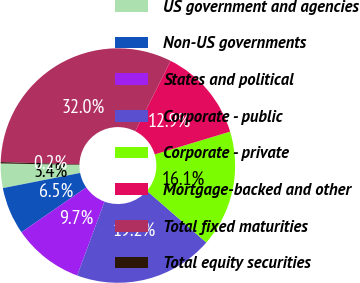Convert chart. <chart><loc_0><loc_0><loc_500><loc_500><pie_chart><fcel>US government and agencies<fcel>Non-US governments<fcel>States and political<fcel>Corporate - public<fcel>Corporate - private<fcel>Mortgage-backed and other<fcel>Total fixed maturities<fcel>Total equity securities<nl><fcel>3.37%<fcel>6.55%<fcel>9.72%<fcel>19.25%<fcel>16.07%<fcel>12.9%<fcel>31.95%<fcel>0.19%<nl></chart> 